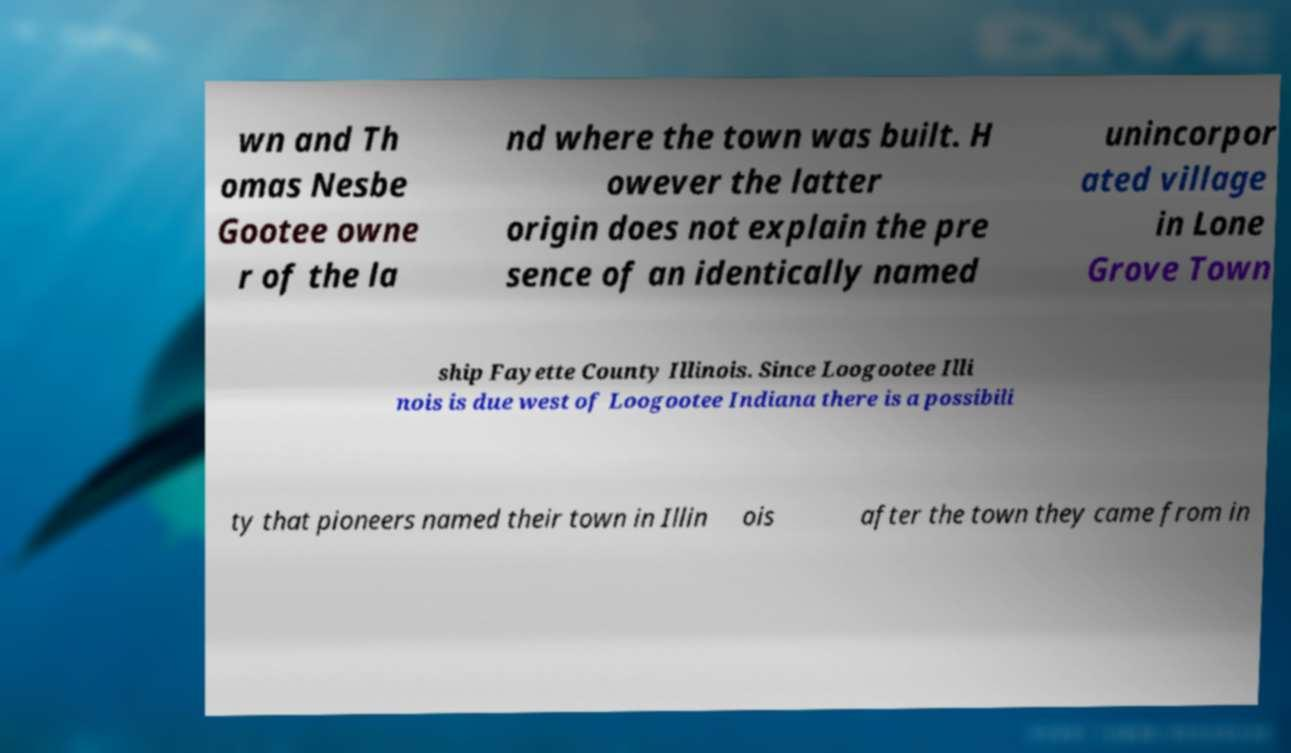Can you accurately transcribe the text from the provided image for me? wn and Th omas Nesbe Gootee owne r of the la nd where the town was built. H owever the latter origin does not explain the pre sence of an identically named unincorpor ated village in Lone Grove Town ship Fayette County Illinois. Since Loogootee Illi nois is due west of Loogootee Indiana there is a possibili ty that pioneers named their town in Illin ois after the town they came from in 